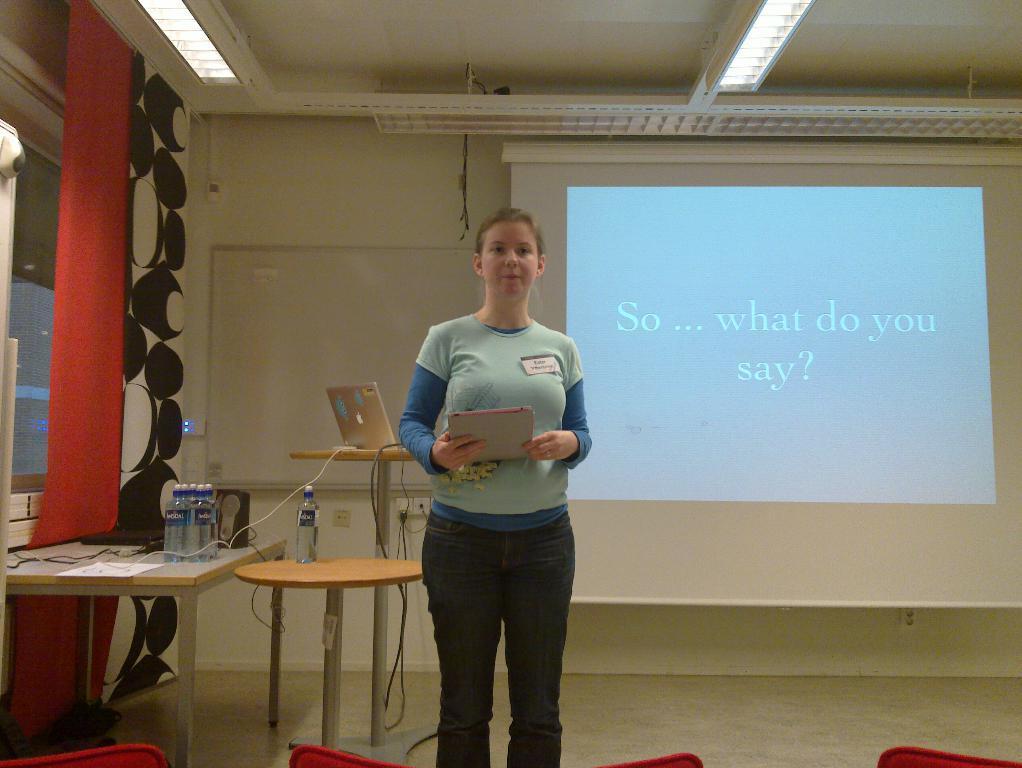Describe this image in one or two sentences. This is an inside view. In the middle of the image there is a woman standing and holding a book in her hand. In the background there is a wall and a screen. On the top I can see the lights. On the left side I can see three tables on that few bottles and a laptop are placed. Beside the table there is wall and a window having a red color curtain to it. On the bottom of the image I can see four red color chairs. 